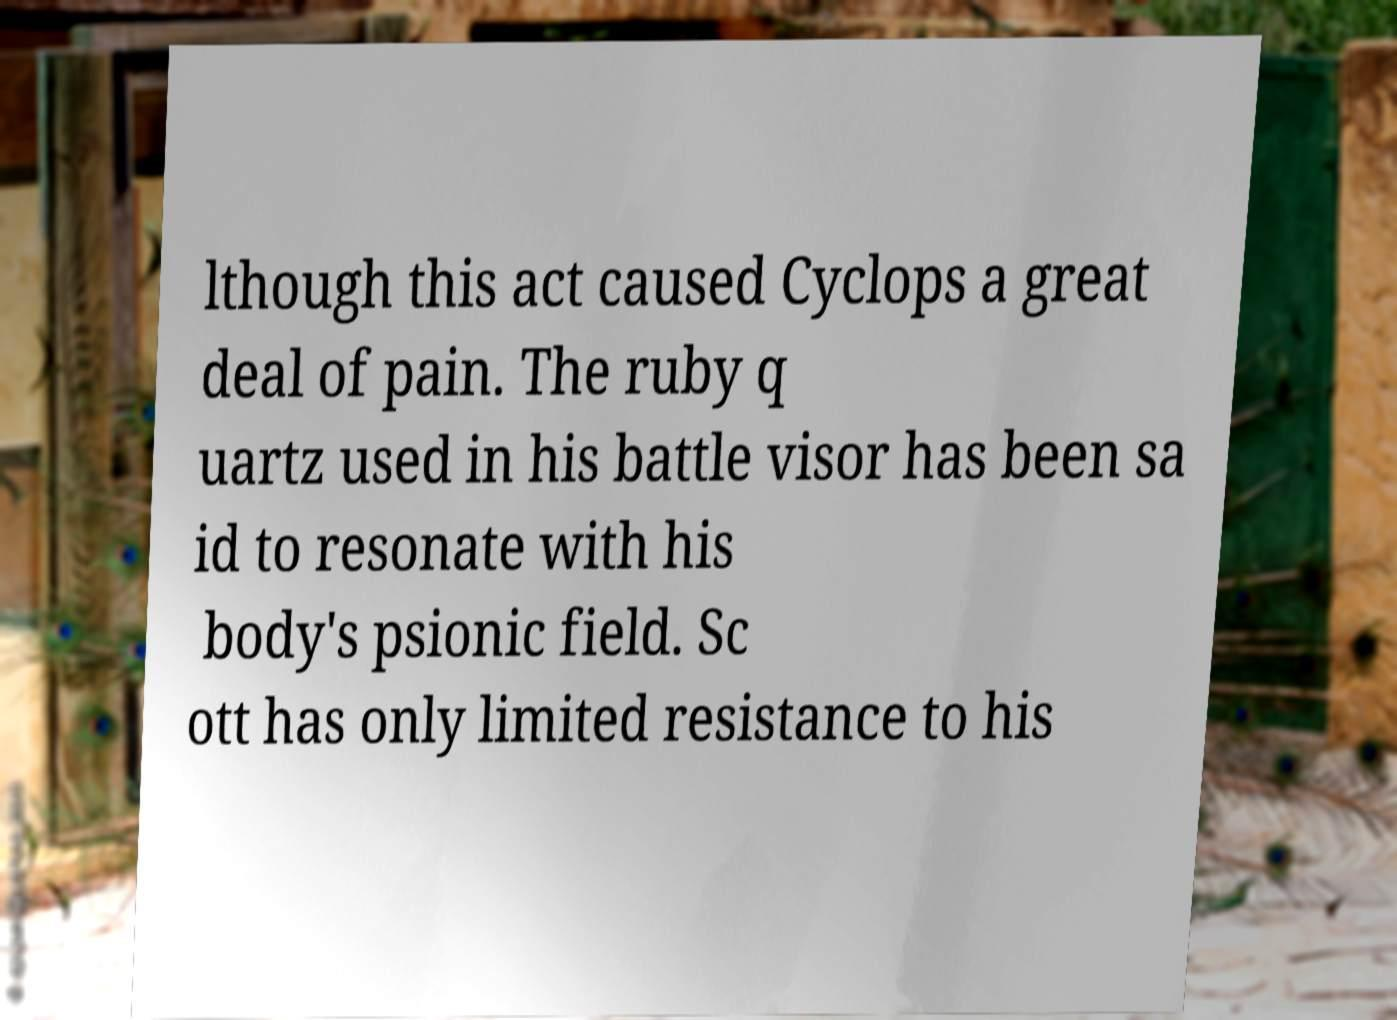Could you assist in decoding the text presented in this image and type it out clearly? lthough this act caused Cyclops a great deal of pain. The ruby q uartz used in his battle visor has been sa id to resonate with his body's psionic field. Sc ott has only limited resistance to his 